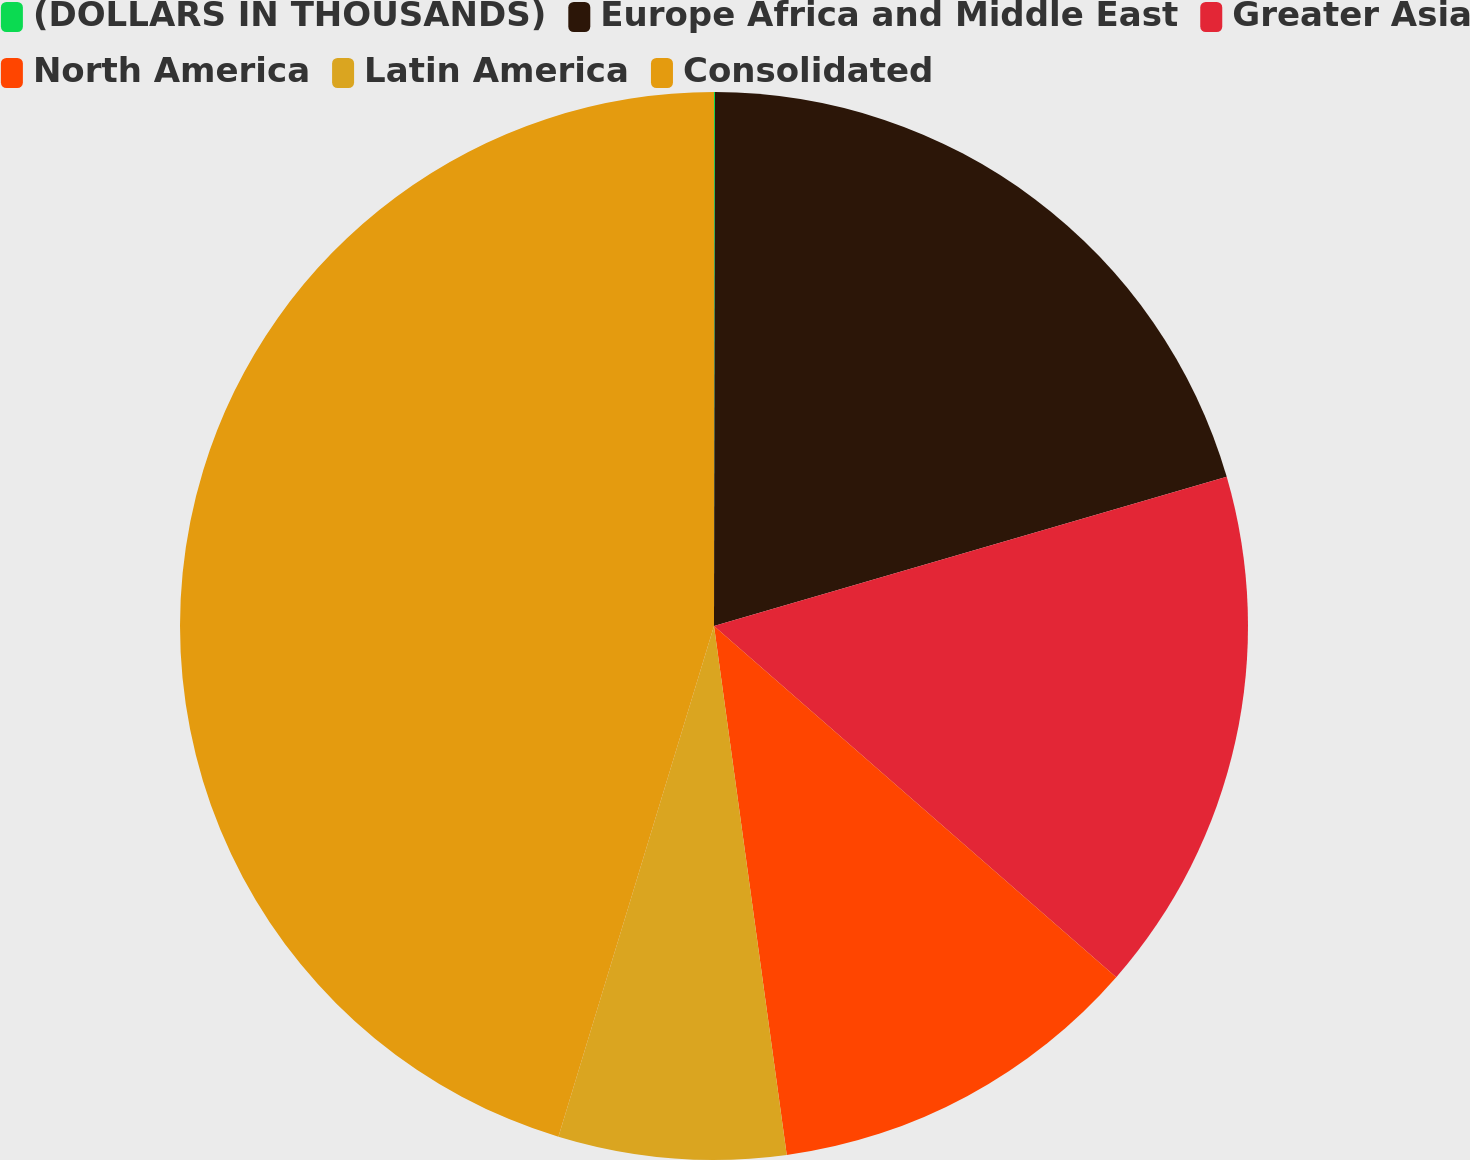<chart> <loc_0><loc_0><loc_500><loc_500><pie_chart><fcel>(DOLLARS IN THOUSANDS)<fcel>Europe Africa and Middle East<fcel>Greater Asia<fcel>North America<fcel>Latin America<fcel>Consolidated<nl><fcel>0.03%<fcel>20.46%<fcel>15.93%<fcel>11.4%<fcel>6.88%<fcel>45.29%<nl></chart> 